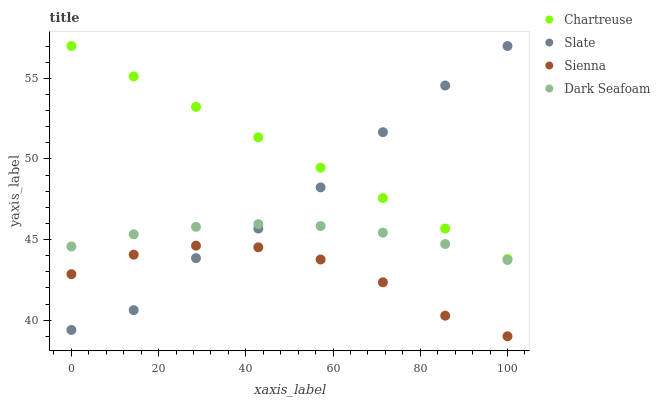Does Sienna have the minimum area under the curve?
Answer yes or no. Yes. Does Chartreuse have the maximum area under the curve?
Answer yes or no. Yes. Does Slate have the minimum area under the curve?
Answer yes or no. No. Does Slate have the maximum area under the curve?
Answer yes or no. No. Is Chartreuse the smoothest?
Answer yes or no. Yes. Is Slate the roughest?
Answer yes or no. Yes. Is Slate the smoothest?
Answer yes or no. No. Is Chartreuse the roughest?
Answer yes or no. No. Does Sienna have the lowest value?
Answer yes or no. Yes. Does Slate have the lowest value?
Answer yes or no. No. Does Slate have the highest value?
Answer yes or no. Yes. Does Dark Seafoam have the highest value?
Answer yes or no. No. Is Dark Seafoam less than Chartreuse?
Answer yes or no. Yes. Is Dark Seafoam greater than Sienna?
Answer yes or no. Yes. Does Slate intersect Chartreuse?
Answer yes or no. Yes. Is Slate less than Chartreuse?
Answer yes or no. No. Is Slate greater than Chartreuse?
Answer yes or no. No. Does Dark Seafoam intersect Chartreuse?
Answer yes or no. No. 